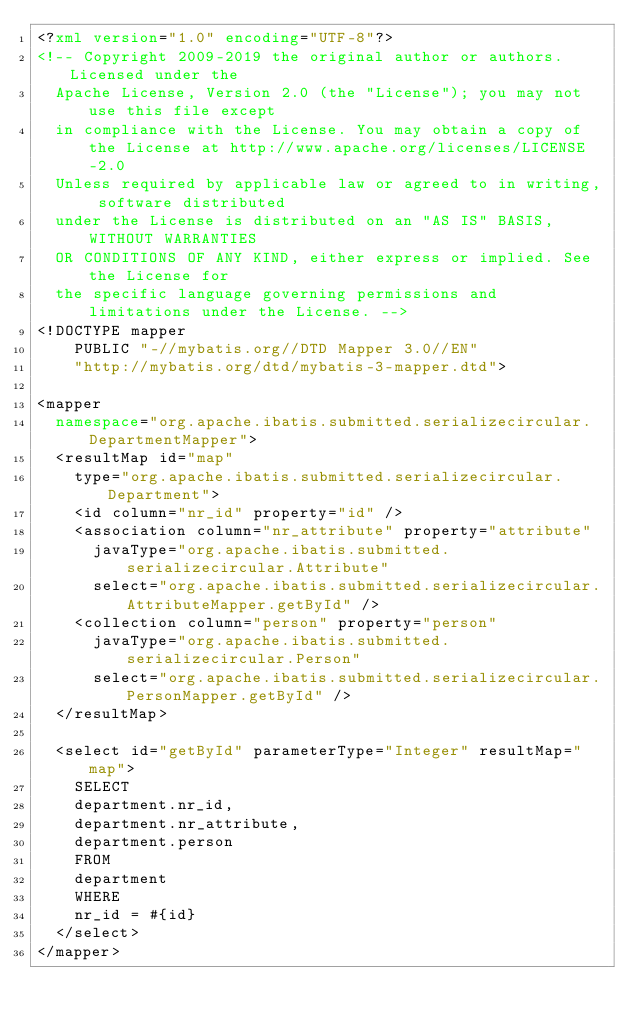Convert code to text. <code><loc_0><loc_0><loc_500><loc_500><_XML_><?xml version="1.0" encoding="UTF-8"?>
<!-- Copyright 2009-2019 the original author or authors. Licensed under the 
	Apache License, Version 2.0 (the "License"); you may not use this file except 
	in compliance with the License. You may obtain a copy of the License at http://www.apache.org/licenses/LICENSE-2.0 
	Unless required by applicable law or agreed to in writing, software distributed 
	under the License is distributed on an "AS IS" BASIS, WITHOUT WARRANTIES 
	OR CONDITIONS OF ANY KIND, either express or implied. See the License for 
	the specific language governing permissions and limitations under the License. -->
<!DOCTYPE mapper
    PUBLIC "-//mybatis.org//DTD Mapper 3.0//EN"
    "http://mybatis.org/dtd/mybatis-3-mapper.dtd">

<mapper
	namespace="org.apache.ibatis.submitted.serializecircular.DepartmentMapper">
	<resultMap id="map"
		type="org.apache.ibatis.submitted.serializecircular.Department">
		<id column="nr_id" property="id" />
		<association column="nr_attribute" property="attribute"
			javaType="org.apache.ibatis.submitted.serializecircular.Attribute"
			select="org.apache.ibatis.submitted.serializecircular.AttributeMapper.getById" />
		<collection column="person" property="person"
			javaType="org.apache.ibatis.submitted.serializecircular.Person"
			select="org.apache.ibatis.submitted.serializecircular.PersonMapper.getById" />
	</resultMap>

	<select id="getById" parameterType="Integer" resultMap="map">
		SELECT
		department.nr_id,
		department.nr_attribute,
		department.person
		FROM
		department
		WHERE
		nr_id = #{id}
	</select>
</mapper>
</code> 